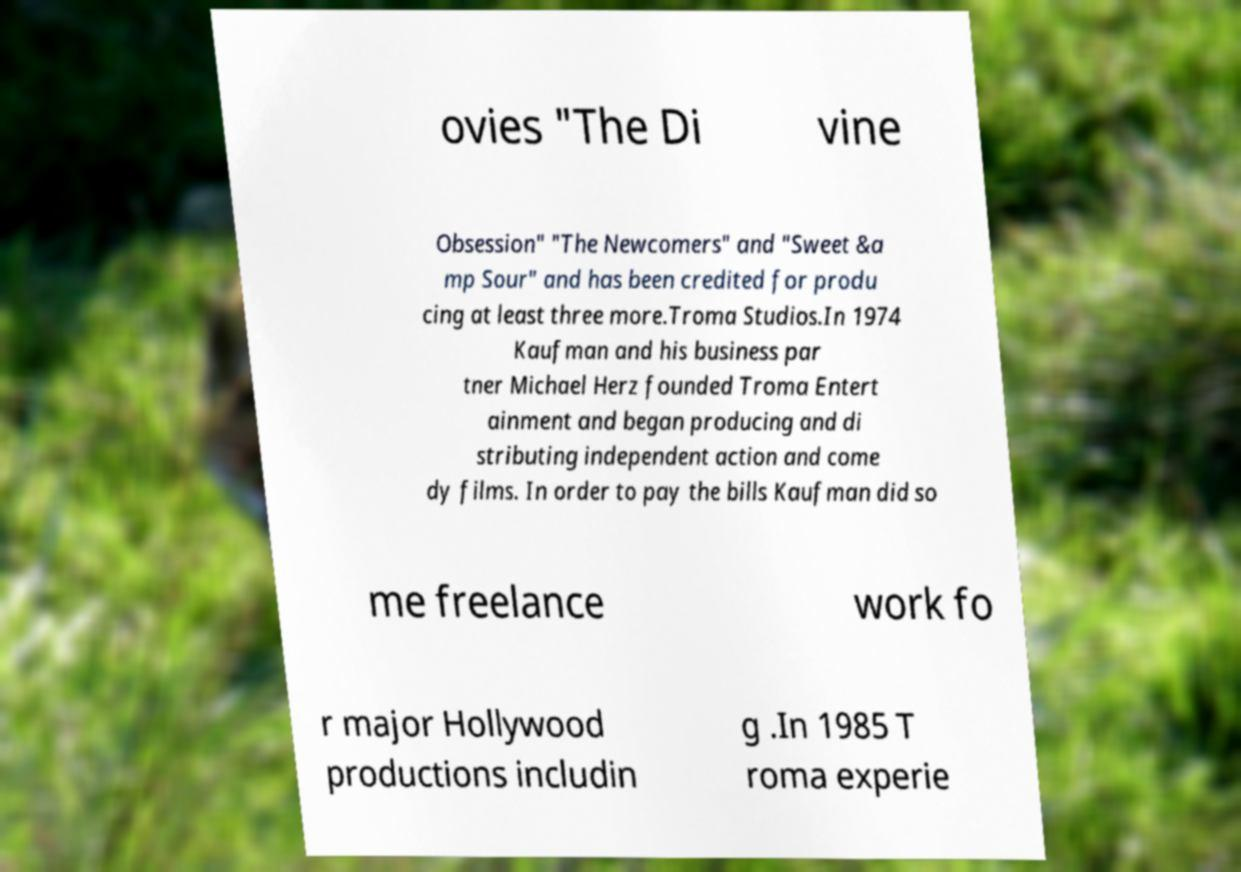For documentation purposes, I need the text within this image transcribed. Could you provide that? ovies "The Di vine Obsession" "The Newcomers" and "Sweet &a mp Sour" and has been credited for produ cing at least three more.Troma Studios.In 1974 Kaufman and his business par tner Michael Herz founded Troma Entert ainment and began producing and di stributing independent action and come dy films. In order to pay the bills Kaufman did so me freelance work fo r major Hollywood productions includin g .In 1985 T roma experie 